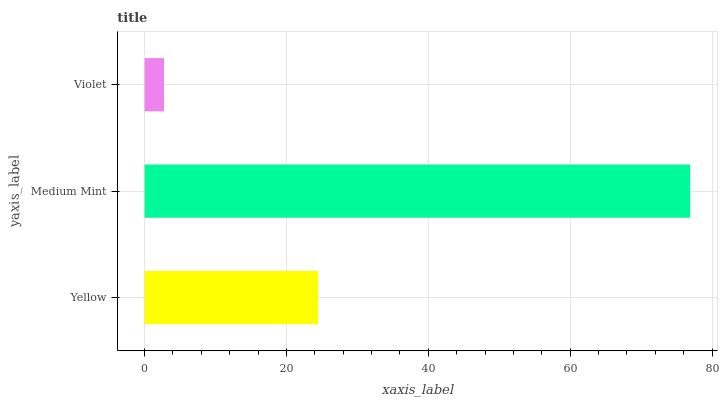Is Violet the minimum?
Answer yes or no. Yes. Is Medium Mint the maximum?
Answer yes or no. Yes. Is Medium Mint the minimum?
Answer yes or no. No. Is Violet the maximum?
Answer yes or no. No. Is Medium Mint greater than Violet?
Answer yes or no. Yes. Is Violet less than Medium Mint?
Answer yes or no. Yes. Is Violet greater than Medium Mint?
Answer yes or no. No. Is Medium Mint less than Violet?
Answer yes or no. No. Is Yellow the high median?
Answer yes or no. Yes. Is Yellow the low median?
Answer yes or no. Yes. Is Medium Mint the high median?
Answer yes or no. No. Is Violet the low median?
Answer yes or no. No. 